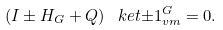<formula> <loc_0><loc_0><loc_500><loc_500>\left ( I \pm H _ { G } + Q \right ) \ k e t { \pm 1 } _ { v m } ^ { G } = 0 .</formula> 